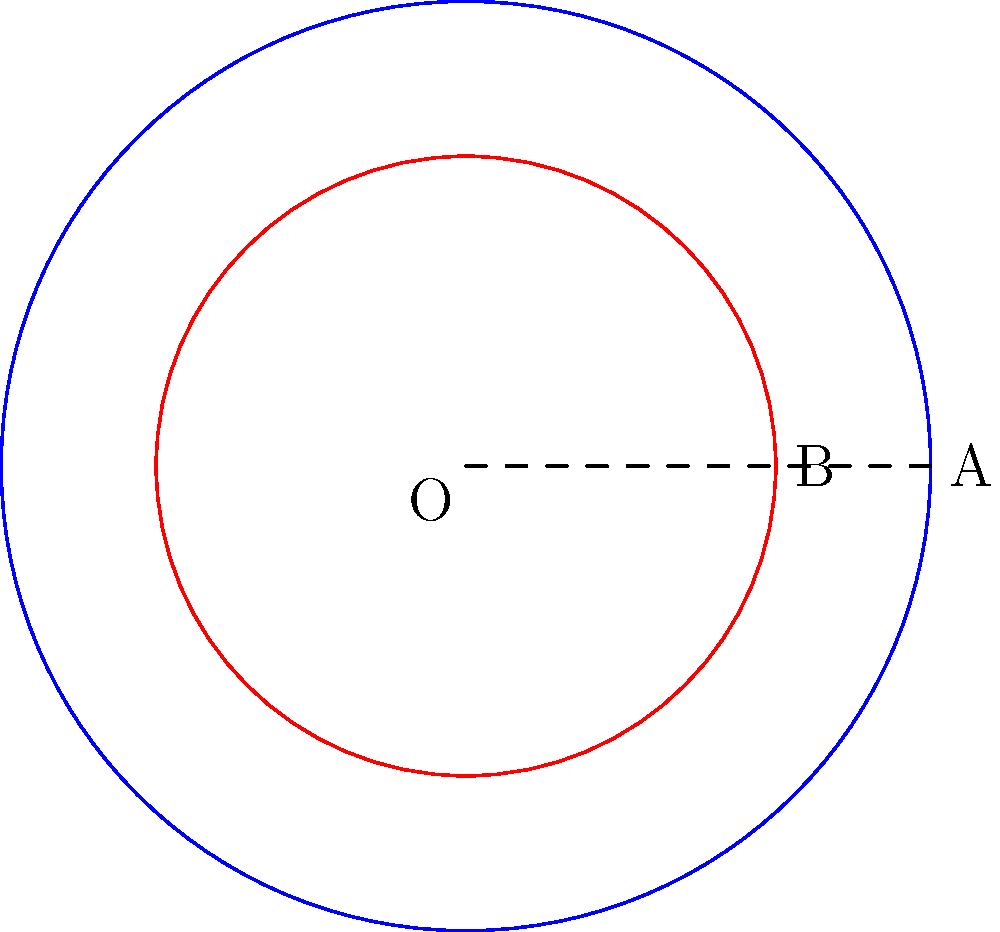In a historical fiction novel set in ancient Rome, the author uses concentric circles to represent the spread of cultural influence. The outer circle A represents the extent of Roman influence, while the inner circle B represents the core Roman territory. If the area between circles A and B is 15π square units, and the radius of circle B is 2 units, what is the radius of circle A? Round your answer to the nearest tenth. Let's approach this step-by-step:

1) Let $r_A$ be the radius of circle A and $r_B$ be the radius of circle B.

2) We're given that $r_B = 2$ units.

3) The area between the circles is the difference between the areas of the two circles:
   $$\text{Area}_{\text{between}} = \pi r_A^2 - \pi r_B^2 = 15\pi$$

4) Substituting the known values:
   $$\pi r_A^2 - \pi (2)^2 = 15\pi$$

5) Simplify:
   $$\pi r_A^2 - 4\pi = 15\pi$$

6) Add $4\pi$ to both sides:
   $$\pi r_A^2 = 19\pi$$

7) Divide both sides by $\pi$:
   $$r_A^2 = 19$$

8) Take the square root of both sides:
   $$r_A = \sqrt{19} \approx 4.358$$

9) Rounding to the nearest tenth:
   $$r_A \approx 4.4$$
Answer: 4.4 units 